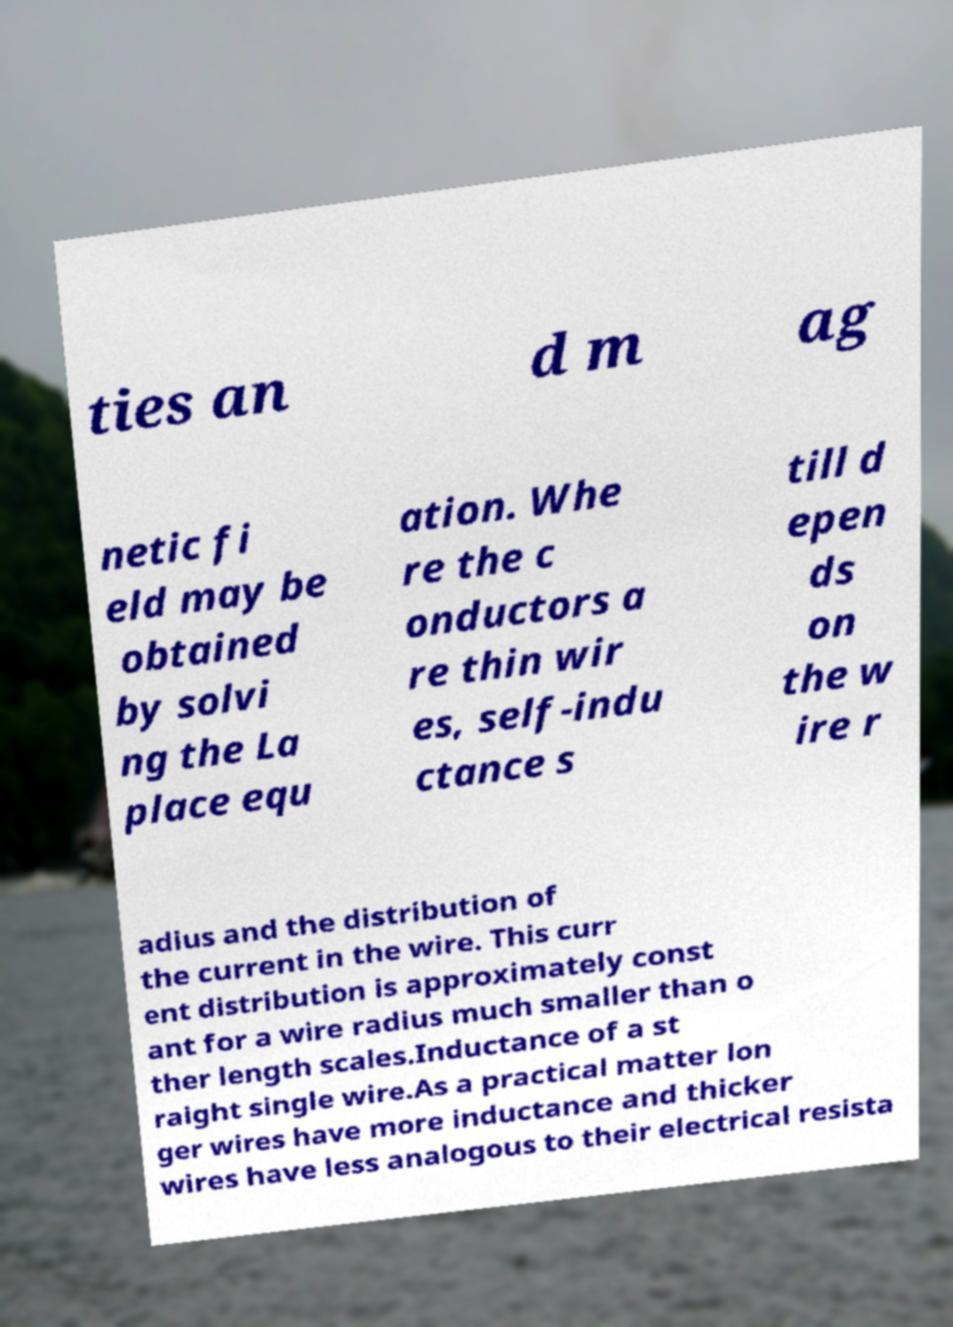Could you assist in decoding the text presented in this image and type it out clearly? ties an d m ag netic fi eld may be obtained by solvi ng the La place equ ation. Whe re the c onductors a re thin wir es, self-indu ctance s till d epen ds on the w ire r adius and the distribution of the current in the wire. This curr ent distribution is approximately const ant for a wire radius much smaller than o ther length scales.Inductance of a st raight single wire.As a practical matter lon ger wires have more inductance and thicker wires have less analogous to their electrical resista 